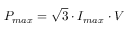Convert formula to latex. <formula><loc_0><loc_0><loc_500><loc_500>\begin{array} { r } { P _ { \max } = \sqrt { 3 } \cdot I _ { \max } \cdot V } \end{array}</formula> 